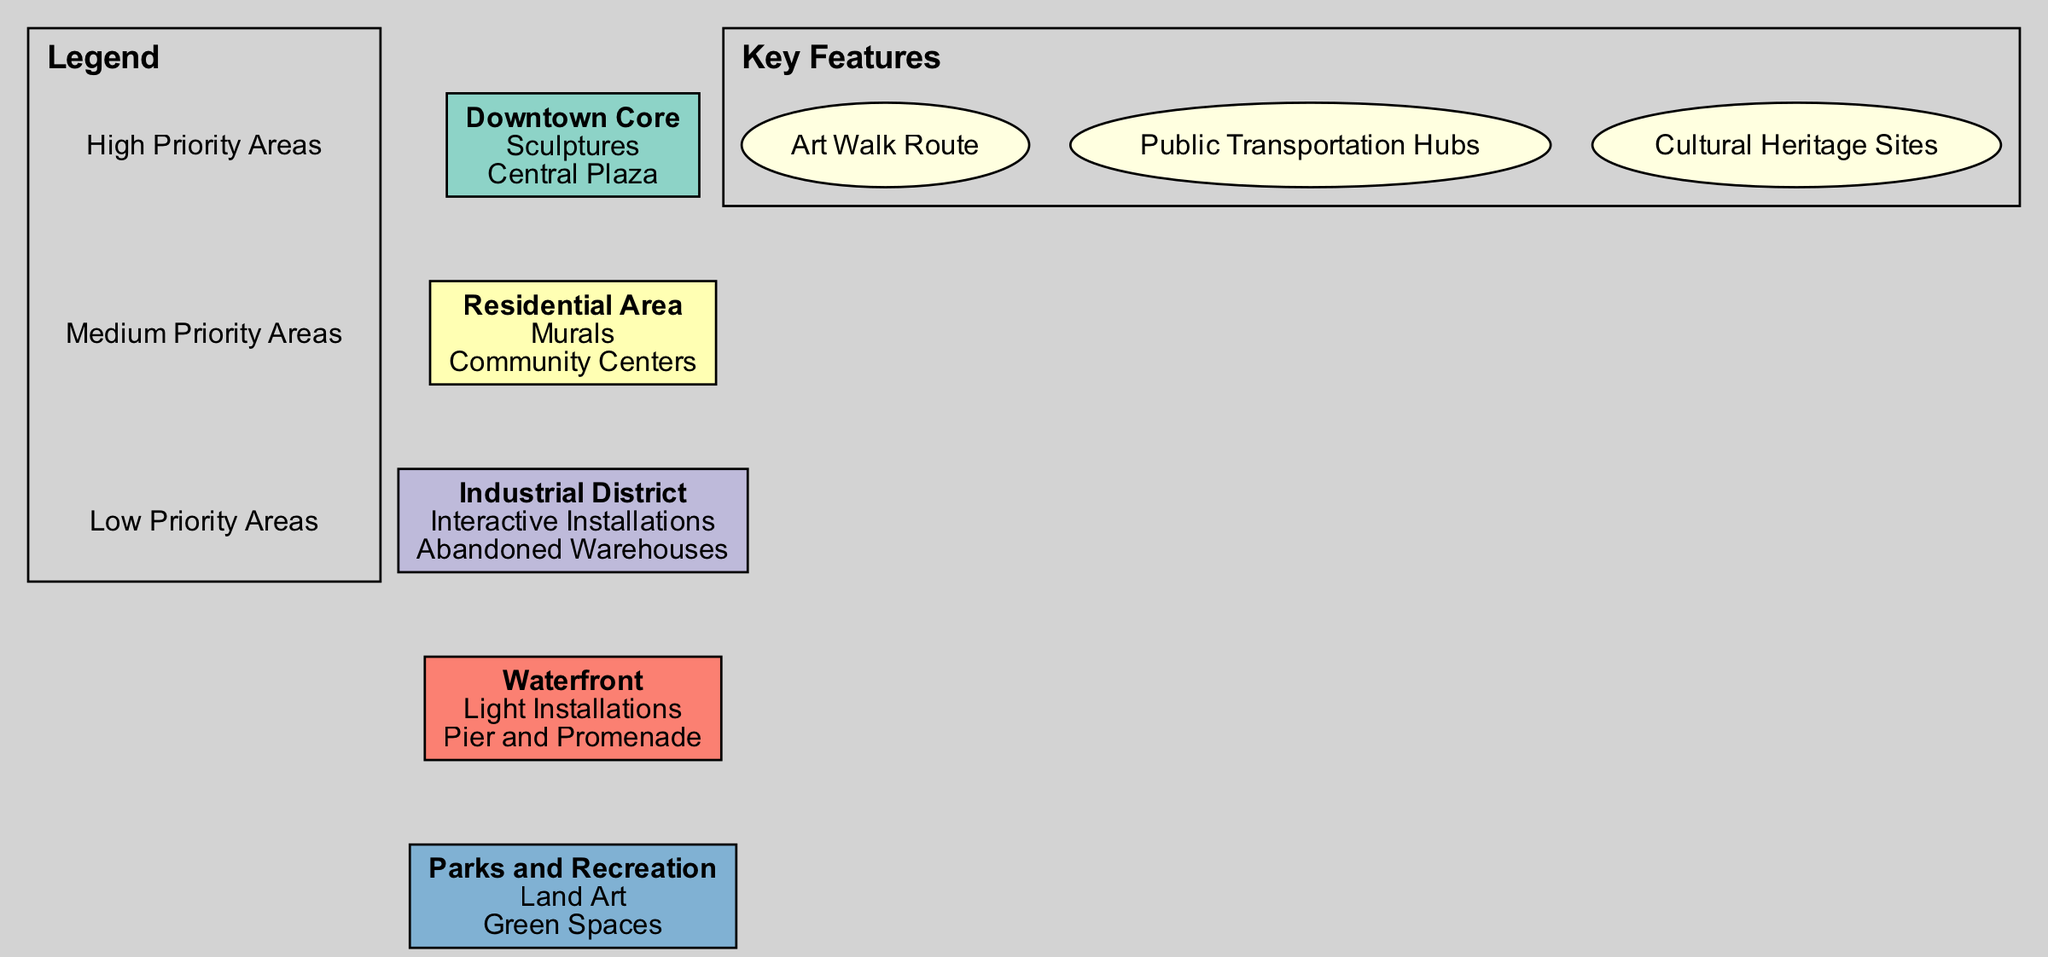What type of art is proposed for the Downtown Core zone? The Downtown Core zone is designated for Sculptures, as indicated by the information displayed in the corresponding node.
Answer: Sculptures Where are the murals planned to be installed? The Residential Area node specifies that murals will be located at Community Centers, providing clear geographical context for this art type.
Answer: Community Centers How many key features are listed in the diagram? The key features section outlines three components: Art Walk Route, Public Transportation Hubs, and Cultural Heritage Sites, which can be counted directly from the labeled section.
Answer: 3 In which zone will interactive installations be placed? The Industrial District is identified in the diagram as the designated zone for interactive installations, specifically in abandoned warehouses.
Answer: Industrial District What is the primary type of art planned for the Waterfront? The Waterfront zone indicates that Light Installations are the primary type of art proposed for this area, as shown in its respective node.
Answer: Light Installations Which zone is assigned the highest priority for public art installation? The Downtown Core typically indicates a higher priority compared to other zones like Residential Area or Industrial District, and this can be inferred from the context of urban planning priorities usually associated with central locations.
Answer: High Priority Areas How do the proposed installations in Parks and Recreation differ from those in the Industrial District? Parks and Recreation focuses on Land Art, while Industrial District emphasizes Interactive Installations, highlighting a thematic difference where one is nature-oriented and the other is technology-oriented.
Answer: Land Art and Interactive Installations Which area is likely to experience more foot traffic given its function in the city? The Downtown Core, being the central hub of activities and amenities, will generally attract more foot traffic compared to the other zones.
Answer: Downtown Core What installation type is most suitable for green spaces? The Parks and Recreation zone is assigned Land Art, suggesting it is optimized for the natural landscape characteristic of green spaces, which supports artistic integration with nature.
Answer: Land Art 